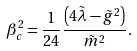Convert formula to latex. <formula><loc_0><loc_0><loc_500><loc_500>\beta _ { c } ^ { 2 } = \frac { 1 } { 2 4 } \frac { \left ( 4 \tilde { \lambda } - { \tilde { g } } ^ { 2 } \right ) } { \tilde { m } ^ { 2 } } .</formula> 